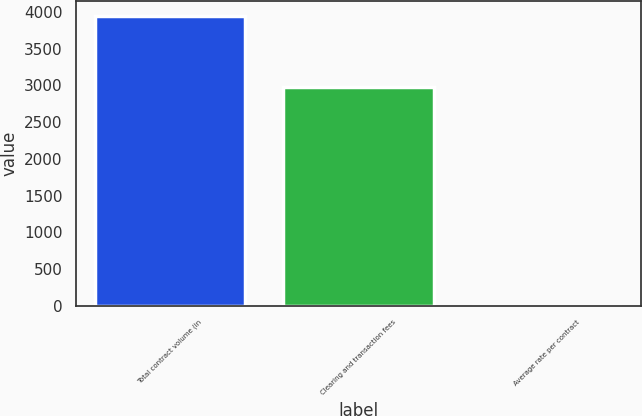Convert chart to OTSL. <chart><loc_0><loc_0><loc_500><loc_500><bar_chart><fcel>Total contract volume (in<fcel>Clearing and transaction fees<fcel>Average rate per contract<nl><fcel>3943.7<fcel>2974.4<fcel>0.75<nl></chart> 